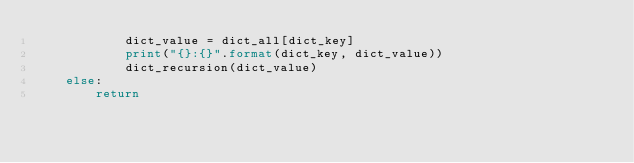<code> <loc_0><loc_0><loc_500><loc_500><_Python_>            dict_value = dict_all[dict_key]
            print("{}:{}".format(dict_key, dict_value))
            dict_recursion(dict_value)
    else:
        return

</code> 